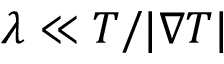<formula> <loc_0><loc_0><loc_500><loc_500>\lambda \ll T / | \nabla T |</formula> 